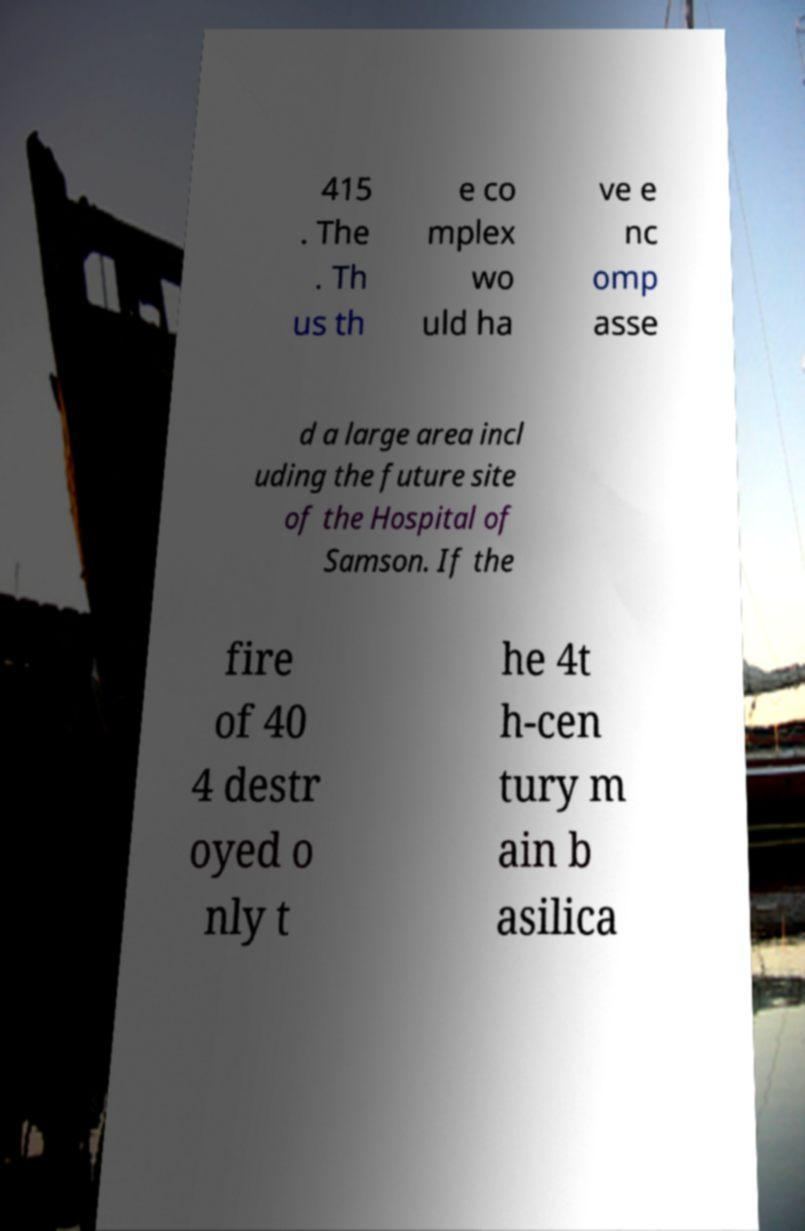Can you read and provide the text displayed in the image?This photo seems to have some interesting text. Can you extract and type it out for me? 415 . The . Th us th e co mplex wo uld ha ve e nc omp asse d a large area incl uding the future site of the Hospital of Samson. If the fire of 40 4 destr oyed o nly t he 4t h-cen tury m ain b asilica 